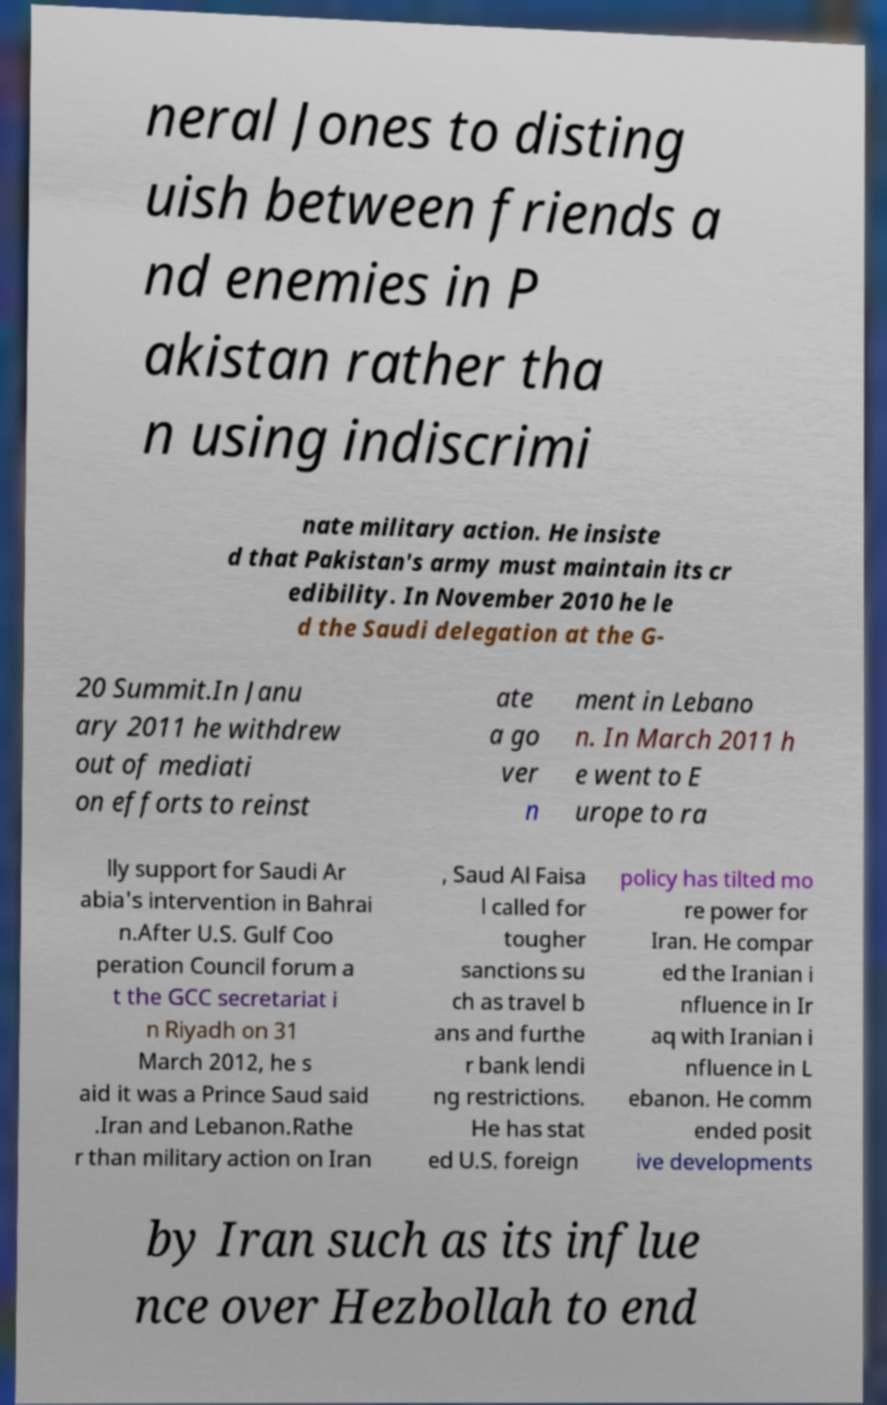Can you read and provide the text displayed in the image?This photo seems to have some interesting text. Can you extract and type it out for me? neral Jones to disting uish between friends a nd enemies in P akistan rather tha n using indiscrimi nate military action. He insiste d that Pakistan's army must maintain its cr edibility. In November 2010 he le d the Saudi delegation at the G- 20 Summit.In Janu ary 2011 he withdrew out of mediati on efforts to reinst ate a go ver n ment in Lebano n. In March 2011 h e went to E urope to ra lly support for Saudi Ar abia's intervention in Bahrai n.After U.S. Gulf Coo peration Council forum a t the GCC secretariat i n Riyadh on 31 March 2012, he s aid it was a Prince Saud said .Iran and Lebanon.Rathe r than military action on Iran , Saud Al Faisa l called for tougher sanctions su ch as travel b ans and furthe r bank lendi ng restrictions. He has stat ed U.S. foreign policy has tilted mo re power for Iran. He compar ed the Iranian i nfluence in Ir aq with Iranian i nfluence in L ebanon. He comm ended posit ive developments by Iran such as its influe nce over Hezbollah to end 